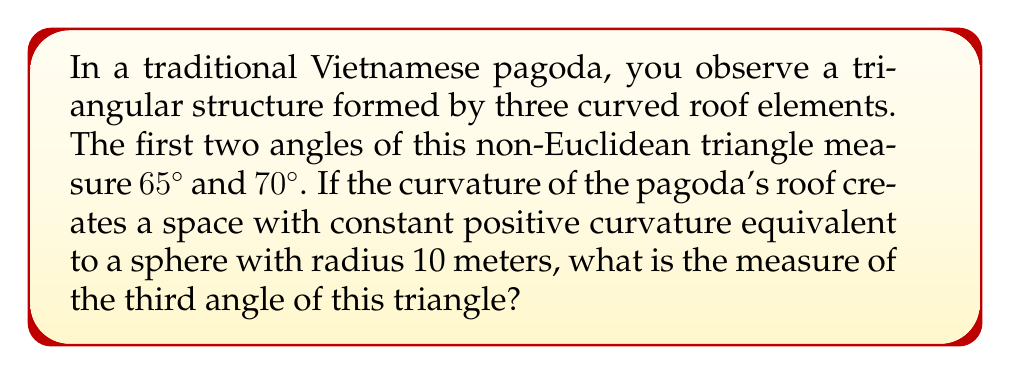Teach me how to tackle this problem. To solve this problem, we need to use the principles of spherical geometry, which is a type of non-Euclidean geometry.

1) In spherical geometry, the sum of angles in a triangle is always greater than $180^\circ$. The excess over $180^\circ$ is related to the area of the triangle and the radius of the sphere.

2) The formula for the area $A$ of a spherical triangle is:

   $$A = R^2(α + β + γ - π)$$

   where $R$ is the radius of the sphere, and $α$, $β$, and $γ$ are the angles of the triangle in radians.

3) We're given that $R = 10$ meters, $α = 65^\circ$, and $β = 70^\circ$. Let's call the unknown angle $γ$.

4) First, convert the known angles to radians:
   
   $65^\circ = \frac{65π}{180} ≈ 1.1345$ radians
   $70^\circ = \frac{70π}{180} ≈ 1.2217$ radians

5) Substitute these into the area formula:

   $$A = 10^2(1.1345 + 1.2217 + γ - π)$$

6) Simplify:

   $$A = 100(2.3562 + γ - π)$$

7) In spherical geometry, the area of a triangle is also related to its angular excess by:

   $$A = R^2E$$

   where $E$ is the angular excess in radians.

8) Equate these two expressions for area:

   $$100(2.3562 + γ - π) = 100E$$

9) Simplify:

   $$2.3562 + γ - π = E$$

10) The angular excess $E$ is also equal to the sum of the angles minus $π$:

    $$E = α + β + γ - π$$

11) Substitute the known values:

    $$E = 1.1345 + 1.2217 + γ - π$$

12) Now we have two expressions for $E$. Equate them:

    $$2.3562 + γ - π = 1.1345 + 1.2217 + γ - π$$

13) Simplify:

    $$2.3562 = 2.3562$$

14) This equation is always true, which means our assumption that the triangle exists on this sphere is correct.

15) To find $γ$, we can use the fact that $α + β + γ = π + E$:

    $$65^\circ + 70^\circ + γ^\circ = 180^\circ + E^\circ$$

16) Solve for $γ$:

    $$γ^\circ = 180^\circ + E^\circ - 135^\circ = 45^\circ + E^\circ$$

17) We can find $E^\circ$ from step 9:

    $$E = 2.3562 + γ - π ≈ 0.2146 \text{ radians} ≈ 12.3^\circ$$

18) Therefore:

    $$γ ≈ 45^\circ + 12.3^\circ = 57.3^\circ$$
Answer: $57.3^\circ$ 